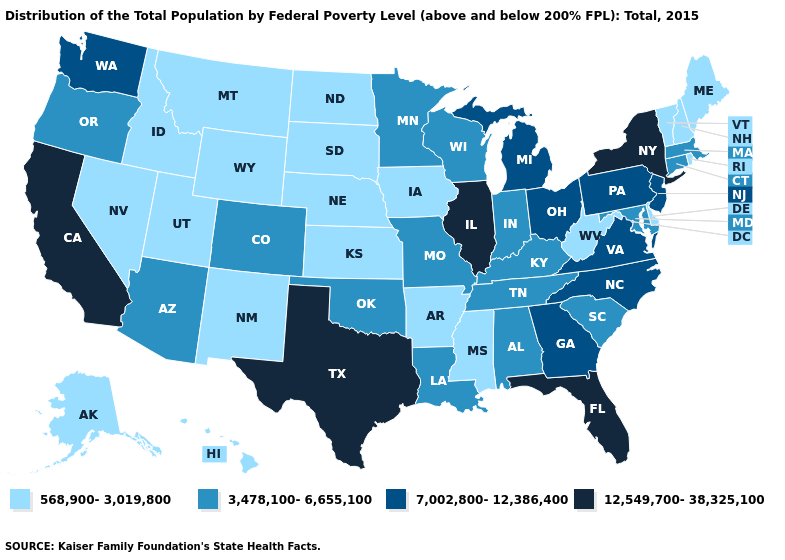What is the value of Maryland?
Keep it brief. 3,478,100-6,655,100. What is the highest value in the USA?
Give a very brief answer. 12,549,700-38,325,100. Among the states that border Delaware , does Pennsylvania have the highest value?
Answer briefly. Yes. Does Oklahoma have a lower value than Virginia?
Quick response, please. Yes. Name the states that have a value in the range 7,002,800-12,386,400?
Quick response, please. Georgia, Michigan, New Jersey, North Carolina, Ohio, Pennsylvania, Virginia, Washington. What is the lowest value in the USA?
Keep it brief. 568,900-3,019,800. Does the map have missing data?
Quick response, please. No. What is the highest value in the USA?
Quick response, please. 12,549,700-38,325,100. Does the map have missing data?
Write a very short answer. No. Name the states that have a value in the range 3,478,100-6,655,100?
Write a very short answer. Alabama, Arizona, Colorado, Connecticut, Indiana, Kentucky, Louisiana, Maryland, Massachusetts, Minnesota, Missouri, Oklahoma, Oregon, South Carolina, Tennessee, Wisconsin. Name the states that have a value in the range 568,900-3,019,800?
Be succinct. Alaska, Arkansas, Delaware, Hawaii, Idaho, Iowa, Kansas, Maine, Mississippi, Montana, Nebraska, Nevada, New Hampshire, New Mexico, North Dakota, Rhode Island, South Dakota, Utah, Vermont, West Virginia, Wyoming. What is the value of Nevada?
Short answer required. 568,900-3,019,800. Does Indiana have a higher value than Missouri?
Write a very short answer. No. What is the value of New York?
Quick response, please. 12,549,700-38,325,100. 